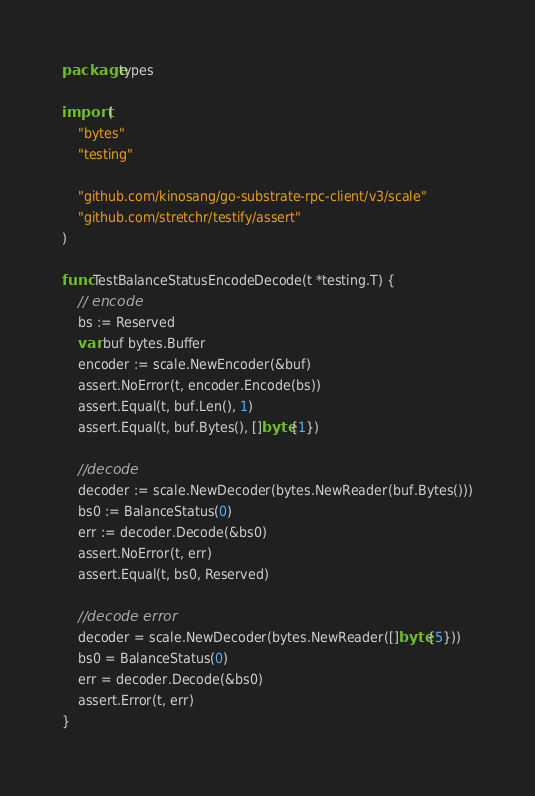<code> <loc_0><loc_0><loc_500><loc_500><_Go_>package types

import (
	"bytes"
	"testing"

	"github.com/kinosang/go-substrate-rpc-client/v3/scale"
	"github.com/stretchr/testify/assert"
)

func TestBalanceStatusEncodeDecode(t *testing.T) {
	// encode
	bs := Reserved
	var buf bytes.Buffer
	encoder := scale.NewEncoder(&buf)
	assert.NoError(t, encoder.Encode(bs))
	assert.Equal(t, buf.Len(), 1)
	assert.Equal(t, buf.Bytes(), []byte{1})

	//decode
	decoder := scale.NewDecoder(bytes.NewReader(buf.Bytes()))
	bs0 := BalanceStatus(0)
	err := decoder.Decode(&bs0)
	assert.NoError(t, err)
	assert.Equal(t, bs0, Reserved)

	//decode error
	decoder = scale.NewDecoder(bytes.NewReader([]byte{5}))
	bs0 = BalanceStatus(0)
	err = decoder.Decode(&bs0)
	assert.Error(t, err)
}
</code> 